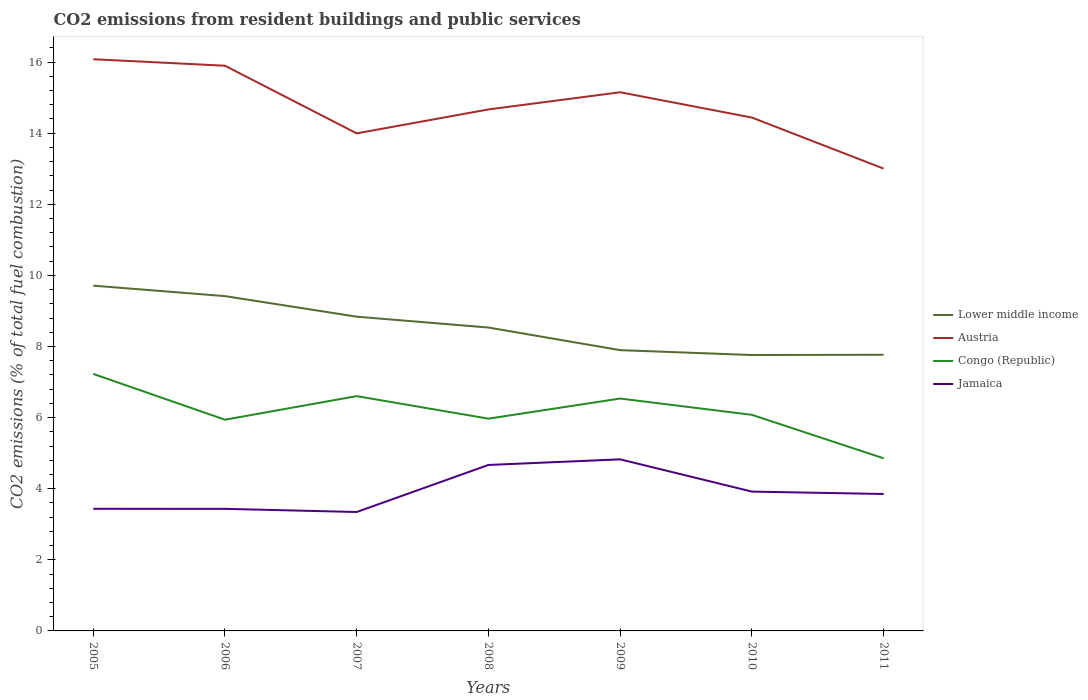How many different coloured lines are there?
Offer a very short reply. 4. Is the number of lines equal to the number of legend labels?
Give a very brief answer. Yes. Across all years, what is the maximum total CO2 emitted in Congo (Republic)?
Make the answer very short. 4.85. In which year was the total CO2 emitted in Lower middle income maximum?
Your answer should be compact. 2010. What is the total total CO2 emitted in Lower middle income in the graph?
Keep it short and to the point. 0.31. What is the difference between the highest and the second highest total CO2 emitted in Austria?
Make the answer very short. 3.08. What is the difference between the highest and the lowest total CO2 emitted in Lower middle income?
Offer a very short reply. 3. Is the total CO2 emitted in Lower middle income strictly greater than the total CO2 emitted in Jamaica over the years?
Make the answer very short. No. How many lines are there?
Your answer should be compact. 4. How many years are there in the graph?
Provide a succinct answer. 7. What is the difference between two consecutive major ticks on the Y-axis?
Your answer should be compact. 2. Where does the legend appear in the graph?
Your answer should be compact. Center right. How many legend labels are there?
Your answer should be very brief. 4. What is the title of the graph?
Provide a succinct answer. CO2 emissions from resident buildings and public services. Does "Spain" appear as one of the legend labels in the graph?
Offer a very short reply. No. What is the label or title of the X-axis?
Ensure brevity in your answer.  Years. What is the label or title of the Y-axis?
Provide a succinct answer. CO2 emissions (% of total fuel combustion). What is the CO2 emissions (% of total fuel combustion) in Lower middle income in 2005?
Make the answer very short. 9.71. What is the CO2 emissions (% of total fuel combustion) in Austria in 2005?
Give a very brief answer. 16.08. What is the CO2 emissions (% of total fuel combustion) in Congo (Republic) in 2005?
Provide a succinct answer. 7.23. What is the CO2 emissions (% of total fuel combustion) of Jamaica in 2005?
Provide a succinct answer. 3.43. What is the CO2 emissions (% of total fuel combustion) of Lower middle income in 2006?
Offer a terse response. 9.42. What is the CO2 emissions (% of total fuel combustion) in Austria in 2006?
Ensure brevity in your answer.  15.9. What is the CO2 emissions (% of total fuel combustion) in Congo (Republic) in 2006?
Give a very brief answer. 5.94. What is the CO2 emissions (% of total fuel combustion) in Jamaica in 2006?
Ensure brevity in your answer.  3.43. What is the CO2 emissions (% of total fuel combustion) in Lower middle income in 2007?
Offer a very short reply. 8.84. What is the CO2 emissions (% of total fuel combustion) of Austria in 2007?
Ensure brevity in your answer.  13.99. What is the CO2 emissions (% of total fuel combustion) of Congo (Republic) in 2007?
Offer a terse response. 6.6. What is the CO2 emissions (% of total fuel combustion) in Jamaica in 2007?
Make the answer very short. 3.34. What is the CO2 emissions (% of total fuel combustion) in Lower middle income in 2008?
Your answer should be compact. 8.53. What is the CO2 emissions (% of total fuel combustion) in Austria in 2008?
Your answer should be compact. 14.67. What is the CO2 emissions (% of total fuel combustion) in Congo (Republic) in 2008?
Your response must be concise. 5.97. What is the CO2 emissions (% of total fuel combustion) of Jamaica in 2008?
Your response must be concise. 4.67. What is the CO2 emissions (% of total fuel combustion) in Lower middle income in 2009?
Give a very brief answer. 7.9. What is the CO2 emissions (% of total fuel combustion) in Austria in 2009?
Offer a terse response. 15.15. What is the CO2 emissions (% of total fuel combustion) in Congo (Republic) in 2009?
Your answer should be very brief. 6.54. What is the CO2 emissions (% of total fuel combustion) of Jamaica in 2009?
Make the answer very short. 4.83. What is the CO2 emissions (% of total fuel combustion) in Lower middle income in 2010?
Your response must be concise. 7.76. What is the CO2 emissions (% of total fuel combustion) of Austria in 2010?
Your answer should be very brief. 14.44. What is the CO2 emissions (% of total fuel combustion) in Congo (Republic) in 2010?
Provide a succinct answer. 6.08. What is the CO2 emissions (% of total fuel combustion) in Jamaica in 2010?
Give a very brief answer. 3.92. What is the CO2 emissions (% of total fuel combustion) in Lower middle income in 2011?
Your answer should be very brief. 7.77. What is the CO2 emissions (% of total fuel combustion) of Austria in 2011?
Provide a succinct answer. 13. What is the CO2 emissions (% of total fuel combustion) in Congo (Republic) in 2011?
Your response must be concise. 4.85. What is the CO2 emissions (% of total fuel combustion) of Jamaica in 2011?
Your answer should be very brief. 3.85. Across all years, what is the maximum CO2 emissions (% of total fuel combustion) of Lower middle income?
Your response must be concise. 9.71. Across all years, what is the maximum CO2 emissions (% of total fuel combustion) of Austria?
Give a very brief answer. 16.08. Across all years, what is the maximum CO2 emissions (% of total fuel combustion) of Congo (Republic)?
Your response must be concise. 7.23. Across all years, what is the maximum CO2 emissions (% of total fuel combustion) of Jamaica?
Keep it short and to the point. 4.83. Across all years, what is the minimum CO2 emissions (% of total fuel combustion) of Lower middle income?
Offer a terse response. 7.76. Across all years, what is the minimum CO2 emissions (% of total fuel combustion) of Austria?
Offer a very short reply. 13. Across all years, what is the minimum CO2 emissions (% of total fuel combustion) in Congo (Republic)?
Offer a very short reply. 4.85. Across all years, what is the minimum CO2 emissions (% of total fuel combustion) in Jamaica?
Offer a terse response. 3.34. What is the total CO2 emissions (% of total fuel combustion) in Lower middle income in the graph?
Keep it short and to the point. 59.92. What is the total CO2 emissions (% of total fuel combustion) in Austria in the graph?
Ensure brevity in your answer.  103.23. What is the total CO2 emissions (% of total fuel combustion) of Congo (Republic) in the graph?
Keep it short and to the point. 43.21. What is the total CO2 emissions (% of total fuel combustion) in Jamaica in the graph?
Your response must be concise. 27.48. What is the difference between the CO2 emissions (% of total fuel combustion) of Lower middle income in 2005 and that in 2006?
Make the answer very short. 0.29. What is the difference between the CO2 emissions (% of total fuel combustion) in Austria in 2005 and that in 2006?
Provide a succinct answer. 0.18. What is the difference between the CO2 emissions (% of total fuel combustion) of Congo (Republic) in 2005 and that in 2006?
Ensure brevity in your answer.  1.29. What is the difference between the CO2 emissions (% of total fuel combustion) of Jamaica in 2005 and that in 2006?
Your answer should be compact. 0. What is the difference between the CO2 emissions (% of total fuel combustion) in Lower middle income in 2005 and that in 2007?
Offer a terse response. 0.87. What is the difference between the CO2 emissions (% of total fuel combustion) of Austria in 2005 and that in 2007?
Ensure brevity in your answer.  2.09. What is the difference between the CO2 emissions (% of total fuel combustion) in Congo (Republic) in 2005 and that in 2007?
Give a very brief answer. 0.63. What is the difference between the CO2 emissions (% of total fuel combustion) in Jamaica in 2005 and that in 2007?
Provide a succinct answer. 0.09. What is the difference between the CO2 emissions (% of total fuel combustion) of Lower middle income in 2005 and that in 2008?
Ensure brevity in your answer.  1.18. What is the difference between the CO2 emissions (% of total fuel combustion) in Austria in 2005 and that in 2008?
Your answer should be compact. 1.41. What is the difference between the CO2 emissions (% of total fuel combustion) of Congo (Republic) in 2005 and that in 2008?
Your answer should be compact. 1.26. What is the difference between the CO2 emissions (% of total fuel combustion) of Jamaica in 2005 and that in 2008?
Ensure brevity in your answer.  -1.23. What is the difference between the CO2 emissions (% of total fuel combustion) of Lower middle income in 2005 and that in 2009?
Give a very brief answer. 1.81. What is the difference between the CO2 emissions (% of total fuel combustion) of Austria in 2005 and that in 2009?
Offer a very short reply. 0.93. What is the difference between the CO2 emissions (% of total fuel combustion) in Congo (Republic) in 2005 and that in 2009?
Ensure brevity in your answer.  0.69. What is the difference between the CO2 emissions (% of total fuel combustion) in Jamaica in 2005 and that in 2009?
Give a very brief answer. -1.39. What is the difference between the CO2 emissions (% of total fuel combustion) of Lower middle income in 2005 and that in 2010?
Ensure brevity in your answer.  1.95. What is the difference between the CO2 emissions (% of total fuel combustion) of Austria in 2005 and that in 2010?
Your response must be concise. 1.64. What is the difference between the CO2 emissions (% of total fuel combustion) of Congo (Republic) in 2005 and that in 2010?
Provide a succinct answer. 1.15. What is the difference between the CO2 emissions (% of total fuel combustion) in Jamaica in 2005 and that in 2010?
Offer a very short reply. -0.48. What is the difference between the CO2 emissions (% of total fuel combustion) of Lower middle income in 2005 and that in 2011?
Your answer should be compact. 1.94. What is the difference between the CO2 emissions (% of total fuel combustion) in Austria in 2005 and that in 2011?
Ensure brevity in your answer.  3.08. What is the difference between the CO2 emissions (% of total fuel combustion) in Congo (Republic) in 2005 and that in 2011?
Keep it short and to the point. 2.37. What is the difference between the CO2 emissions (% of total fuel combustion) of Jamaica in 2005 and that in 2011?
Your answer should be compact. -0.42. What is the difference between the CO2 emissions (% of total fuel combustion) of Lower middle income in 2006 and that in 2007?
Keep it short and to the point. 0.58. What is the difference between the CO2 emissions (% of total fuel combustion) in Austria in 2006 and that in 2007?
Provide a succinct answer. 1.9. What is the difference between the CO2 emissions (% of total fuel combustion) in Congo (Republic) in 2006 and that in 2007?
Provide a succinct answer. -0.66. What is the difference between the CO2 emissions (% of total fuel combustion) in Jamaica in 2006 and that in 2007?
Provide a succinct answer. 0.09. What is the difference between the CO2 emissions (% of total fuel combustion) in Lower middle income in 2006 and that in 2008?
Ensure brevity in your answer.  0.88. What is the difference between the CO2 emissions (% of total fuel combustion) in Austria in 2006 and that in 2008?
Make the answer very short. 1.23. What is the difference between the CO2 emissions (% of total fuel combustion) of Congo (Republic) in 2006 and that in 2008?
Your answer should be compact. -0.03. What is the difference between the CO2 emissions (% of total fuel combustion) in Jamaica in 2006 and that in 2008?
Provide a short and direct response. -1.23. What is the difference between the CO2 emissions (% of total fuel combustion) in Lower middle income in 2006 and that in 2009?
Your answer should be compact. 1.52. What is the difference between the CO2 emissions (% of total fuel combustion) in Austria in 2006 and that in 2009?
Provide a succinct answer. 0.75. What is the difference between the CO2 emissions (% of total fuel combustion) of Congo (Republic) in 2006 and that in 2009?
Offer a terse response. -0.6. What is the difference between the CO2 emissions (% of total fuel combustion) in Jamaica in 2006 and that in 2009?
Offer a very short reply. -1.39. What is the difference between the CO2 emissions (% of total fuel combustion) in Lower middle income in 2006 and that in 2010?
Provide a short and direct response. 1.66. What is the difference between the CO2 emissions (% of total fuel combustion) in Austria in 2006 and that in 2010?
Your answer should be very brief. 1.46. What is the difference between the CO2 emissions (% of total fuel combustion) in Congo (Republic) in 2006 and that in 2010?
Ensure brevity in your answer.  -0.14. What is the difference between the CO2 emissions (% of total fuel combustion) of Jamaica in 2006 and that in 2010?
Your answer should be compact. -0.49. What is the difference between the CO2 emissions (% of total fuel combustion) of Lower middle income in 2006 and that in 2011?
Offer a very short reply. 1.65. What is the difference between the CO2 emissions (% of total fuel combustion) in Austria in 2006 and that in 2011?
Offer a terse response. 2.89. What is the difference between the CO2 emissions (% of total fuel combustion) in Congo (Republic) in 2006 and that in 2011?
Provide a succinct answer. 1.09. What is the difference between the CO2 emissions (% of total fuel combustion) in Jamaica in 2006 and that in 2011?
Offer a terse response. -0.42. What is the difference between the CO2 emissions (% of total fuel combustion) in Lower middle income in 2007 and that in 2008?
Offer a very short reply. 0.31. What is the difference between the CO2 emissions (% of total fuel combustion) of Austria in 2007 and that in 2008?
Offer a very short reply. -0.67. What is the difference between the CO2 emissions (% of total fuel combustion) in Congo (Republic) in 2007 and that in 2008?
Provide a succinct answer. 0.63. What is the difference between the CO2 emissions (% of total fuel combustion) of Jamaica in 2007 and that in 2008?
Your answer should be very brief. -1.32. What is the difference between the CO2 emissions (% of total fuel combustion) of Lower middle income in 2007 and that in 2009?
Give a very brief answer. 0.94. What is the difference between the CO2 emissions (% of total fuel combustion) in Austria in 2007 and that in 2009?
Ensure brevity in your answer.  -1.16. What is the difference between the CO2 emissions (% of total fuel combustion) of Congo (Republic) in 2007 and that in 2009?
Your response must be concise. 0.07. What is the difference between the CO2 emissions (% of total fuel combustion) of Jamaica in 2007 and that in 2009?
Make the answer very short. -1.48. What is the difference between the CO2 emissions (% of total fuel combustion) in Lower middle income in 2007 and that in 2010?
Offer a terse response. 1.08. What is the difference between the CO2 emissions (% of total fuel combustion) of Austria in 2007 and that in 2010?
Make the answer very short. -0.44. What is the difference between the CO2 emissions (% of total fuel combustion) of Congo (Republic) in 2007 and that in 2010?
Give a very brief answer. 0.53. What is the difference between the CO2 emissions (% of total fuel combustion) in Jamaica in 2007 and that in 2010?
Provide a succinct answer. -0.57. What is the difference between the CO2 emissions (% of total fuel combustion) in Lower middle income in 2007 and that in 2011?
Ensure brevity in your answer.  1.07. What is the difference between the CO2 emissions (% of total fuel combustion) of Congo (Republic) in 2007 and that in 2011?
Your response must be concise. 1.75. What is the difference between the CO2 emissions (% of total fuel combustion) of Jamaica in 2007 and that in 2011?
Your response must be concise. -0.51. What is the difference between the CO2 emissions (% of total fuel combustion) of Lower middle income in 2008 and that in 2009?
Your answer should be very brief. 0.64. What is the difference between the CO2 emissions (% of total fuel combustion) in Austria in 2008 and that in 2009?
Ensure brevity in your answer.  -0.48. What is the difference between the CO2 emissions (% of total fuel combustion) of Congo (Republic) in 2008 and that in 2009?
Provide a succinct answer. -0.57. What is the difference between the CO2 emissions (% of total fuel combustion) in Jamaica in 2008 and that in 2009?
Ensure brevity in your answer.  -0.16. What is the difference between the CO2 emissions (% of total fuel combustion) of Lower middle income in 2008 and that in 2010?
Offer a terse response. 0.77. What is the difference between the CO2 emissions (% of total fuel combustion) in Austria in 2008 and that in 2010?
Keep it short and to the point. 0.23. What is the difference between the CO2 emissions (% of total fuel combustion) of Congo (Republic) in 2008 and that in 2010?
Give a very brief answer. -0.11. What is the difference between the CO2 emissions (% of total fuel combustion) in Jamaica in 2008 and that in 2010?
Your response must be concise. 0.75. What is the difference between the CO2 emissions (% of total fuel combustion) in Lower middle income in 2008 and that in 2011?
Provide a succinct answer. 0.77. What is the difference between the CO2 emissions (% of total fuel combustion) of Austria in 2008 and that in 2011?
Offer a very short reply. 1.66. What is the difference between the CO2 emissions (% of total fuel combustion) in Congo (Republic) in 2008 and that in 2011?
Keep it short and to the point. 1.12. What is the difference between the CO2 emissions (% of total fuel combustion) in Jamaica in 2008 and that in 2011?
Keep it short and to the point. 0.82. What is the difference between the CO2 emissions (% of total fuel combustion) in Lower middle income in 2009 and that in 2010?
Provide a succinct answer. 0.14. What is the difference between the CO2 emissions (% of total fuel combustion) in Austria in 2009 and that in 2010?
Your answer should be very brief. 0.71. What is the difference between the CO2 emissions (% of total fuel combustion) of Congo (Republic) in 2009 and that in 2010?
Provide a short and direct response. 0.46. What is the difference between the CO2 emissions (% of total fuel combustion) of Jamaica in 2009 and that in 2010?
Offer a very short reply. 0.91. What is the difference between the CO2 emissions (% of total fuel combustion) of Lower middle income in 2009 and that in 2011?
Your response must be concise. 0.13. What is the difference between the CO2 emissions (% of total fuel combustion) in Austria in 2009 and that in 2011?
Give a very brief answer. 2.15. What is the difference between the CO2 emissions (% of total fuel combustion) in Congo (Republic) in 2009 and that in 2011?
Your response must be concise. 1.68. What is the difference between the CO2 emissions (% of total fuel combustion) in Jamaica in 2009 and that in 2011?
Provide a succinct answer. 0.97. What is the difference between the CO2 emissions (% of total fuel combustion) in Lower middle income in 2010 and that in 2011?
Offer a very short reply. -0.01. What is the difference between the CO2 emissions (% of total fuel combustion) of Austria in 2010 and that in 2011?
Your answer should be very brief. 1.44. What is the difference between the CO2 emissions (% of total fuel combustion) in Congo (Republic) in 2010 and that in 2011?
Give a very brief answer. 1.22. What is the difference between the CO2 emissions (% of total fuel combustion) in Jamaica in 2010 and that in 2011?
Offer a terse response. 0.07. What is the difference between the CO2 emissions (% of total fuel combustion) of Lower middle income in 2005 and the CO2 emissions (% of total fuel combustion) of Austria in 2006?
Your response must be concise. -6.19. What is the difference between the CO2 emissions (% of total fuel combustion) of Lower middle income in 2005 and the CO2 emissions (% of total fuel combustion) of Congo (Republic) in 2006?
Your answer should be very brief. 3.77. What is the difference between the CO2 emissions (% of total fuel combustion) of Lower middle income in 2005 and the CO2 emissions (% of total fuel combustion) of Jamaica in 2006?
Your answer should be very brief. 6.28. What is the difference between the CO2 emissions (% of total fuel combustion) of Austria in 2005 and the CO2 emissions (% of total fuel combustion) of Congo (Republic) in 2006?
Your answer should be very brief. 10.14. What is the difference between the CO2 emissions (% of total fuel combustion) in Austria in 2005 and the CO2 emissions (% of total fuel combustion) in Jamaica in 2006?
Your response must be concise. 12.65. What is the difference between the CO2 emissions (% of total fuel combustion) of Congo (Republic) in 2005 and the CO2 emissions (% of total fuel combustion) of Jamaica in 2006?
Your response must be concise. 3.8. What is the difference between the CO2 emissions (% of total fuel combustion) of Lower middle income in 2005 and the CO2 emissions (% of total fuel combustion) of Austria in 2007?
Give a very brief answer. -4.28. What is the difference between the CO2 emissions (% of total fuel combustion) in Lower middle income in 2005 and the CO2 emissions (% of total fuel combustion) in Congo (Republic) in 2007?
Keep it short and to the point. 3.11. What is the difference between the CO2 emissions (% of total fuel combustion) of Lower middle income in 2005 and the CO2 emissions (% of total fuel combustion) of Jamaica in 2007?
Your answer should be compact. 6.37. What is the difference between the CO2 emissions (% of total fuel combustion) of Austria in 2005 and the CO2 emissions (% of total fuel combustion) of Congo (Republic) in 2007?
Offer a very short reply. 9.48. What is the difference between the CO2 emissions (% of total fuel combustion) of Austria in 2005 and the CO2 emissions (% of total fuel combustion) of Jamaica in 2007?
Keep it short and to the point. 12.73. What is the difference between the CO2 emissions (% of total fuel combustion) of Congo (Republic) in 2005 and the CO2 emissions (% of total fuel combustion) of Jamaica in 2007?
Your response must be concise. 3.88. What is the difference between the CO2 emissions (% of total fuel combustion) of Lower middle income in 2005 and the CO2 emissions (% of total fuel combustion) of Austria in 2008?
Keep it short and to the point. -4.96. What is the difference between the CO2 emissions (% of total fuel combustion) of Lower middle income in 2005 and the CO2 emissions (% of total fuel combustion) of Congo (Republic) in 2008?
Give a very brief answer. 3.74. What is the difference between the CO2 emissions (% of total fuel combustion) in Lower middle income in 2005 and the CO2 emissions (% of total fuel combustion) in Jamaica in 2008?
Your answer should be very brief. 5.04. What is the difference between the CO2 emissions (% of total fuel combustion) in Austria in 2005 and the CO2 emissions (% of total fuel combustion) in Congo (Republic) in 2008?
Provide a succinct answer. 10.11. What is the difference between the CO2 emissions (% of total fuel combustion) of Austria in 2005 and the CO2 emissions (% of total fuel combustion) of Jamaica in 2008?
Your response must be concise. 11.41. What is the difference between the CO2 emissions (% of total fuel combustion) of Congo (Republic) in 2005 and the CO2 emissions (% of total fuel combustion) of Jamaica in 2008?
Your response must be concise. 2.56. What is the difference between the CO2 emissions (% of total fuel combustion) of Lower middle income in 2005 and the CO2 emissions (% of total fuel combustion) of Austria in 2009?
Give a very brief answer. -5.44. What is the difference between the CO2 emissions (% of total fuel combustion) of Lower middle income in 2005 and the CO2 emissions (% of total fuel combustion) of Congo (Republic) in 2009?
Provide a short and direct response. 3.17. What is the difference between the CO2 emissions (% of total fuel combustion) of Lower middle income in 2005 and the CO2 emissions (% of total fuel combustion) of Jamaica in 2009?
Give a very brief answer. 4.88. What is the difference between the CO2 emissions (% of total fuel combustion) of Austria in 2005 and the CO2 emissions (% of total fuel combustion) of Congo (Republic) in 2009?
Give a very brief answer. 9.54. What is the difference between the CO2 emissions (% of total fuel combustion) in Austria in 2005 and the CO2 emissions (% of total fuel combustion) in Jamaica in 2009?
Make the answer very short. 11.25. What is the difference between the CO2 emissions (% of total fuel combustion) in Congo (Republic) in 2005 and the CO2 emissions (% of total fuel combustion) in Jamaica in 2009?
Your answer should be very brief. 2.4. What is the difference between the CO2 emissions (% of total fuel combustion) in Lower middle income in 2005 and the CO2 emissions (% of total fuel combustion) in Austria in 2010?
Provide a succinct answer. -4.73. What is the difference between the CO2 emissions (% of total fuel combustion) of Lower middle income in 2005 and the CO2 emissions (% of total fuel combustion) of Congo (Republic) in 2010?
Make the answer very short. 3.63. What is the difference between the CO2 emissions (% of total fuel combustion) in Lower middle income in 2005 and the CO2 emissions (% of total fuel combustion) in Jamaica in 2010?
Provide a succinct answer. 5.79. What is the difference between the CO2 emissions (% of total fuel combustion) in Austria in 2005 and the CO2 emissions (% of total fuel combustion) in Congo (Republic) in 2010?
Give a very brief answer. 10. What is the difference between the CO2 emissions (% of total fuel combustion) of Austria in 2005 and the CO2 emissions (% of total fuel combustion) of Jamaica in 2010?
Your answer should be compact. 12.16. What is the difference between the CO2 emissions (% of total fuel combustion) of Congo (Republic) in 2005 and the CO2 emissions (% of total fuel combustion) of Jamaica in 2010?
Keep it short and to the point. 3.31. What is the difference between the CO2 emissions (% of total fuel combustion) in Lower middle income in 2005 and the CO2 emissions (% of total fuel combustion) in Austria in 2011?
Keep it short and to the point. -3.29. What is the difference between the CO2 emissions (% of total fuel combustion) of Lower middle income in 2005 and the CO2 emissions (% of total fuel combustion) of Congo (Republic) in 2011?
Provide a succinct answer. 4.86. What is the difference between the CO2 emissions (% of total fuel combustion) of Lower middle income in 2005 and the CO2 emissions (% of total fuel combustion) of Jamaica in 2011?
Your answer should be compact. 5.86. What is the difference between the CO2 emissions (% of total fuel combustion) of Austria in 2005 and the CO2 emissions (% of total fuel combustion) of Congo (Republic) in 2011?
Ensure brevity in your answer.  11.22. What is the difference between the CO2 emissions (% of total fuel combustion) in Austria in 2005 and the CO2 emissions (% of total fuel combustion) in Jamaica in 2011?
Make the answer very short. 12.23. What is the difference between the CO2 emissions (% of total fuel combustion) of Congo (Republic) in 2005 and the CO2 emissions (% of total fuel combustion) of Jamaica in 2011?
Your response must be concise. 3.38. What is the difference between the CO2 emissions (% of total fuel combustion) of Lower middle income in 2006 and the CO2 emissions (% of total fuel combustion) of Austria in 2007?
Keep it short and to the point. -4.58. What is the difference between the CO2 emissions (% of total fuel combustion) of Lower middle income in 2006 and the CO2 emissions (% of total fuel combustion) of Congo (Republic) in 2007?
Your answer should be very brief. 2.81. What is the difference between the CO2 emissions (% of total fuel combustion) of Lower middle income in 2006 and the CO2 emissions (% of total fuel combustion) of Jamaica in 2007?
Make the answer very short. 6.07. What is the difference between the CO2 emissions (% of total fuel combustion) of Austria in 2006 and the CO2 emissions (% of total fuel combustion) of Congo (Republic) in 2007?
Offer a very short reply. 9.29. What is the difference between the CO2 emissions (% of total fuel combustion) in Austria in 2006 and the CO2 emissions (% of total fuel combustion) in Jamaica in 2007?
Offer a very short reply. 12.55. What is the difference between the CO2 emissions (% of total fuel combustion) in Congo (Republic) in 2006 and the CO2 emissions (% of total fuel combustion) in Jamaica in 2007?
Make the answer very short. 2.6. What is the difference between the CO2 emissions (% of total fuel combustion) of Lower middle income in 2006 and the CO2 emissions (% of total fuel combustion) of Austria in 2008?
Your answer should be compact. -5.25. What is the difference between the CO2 emissions (% of total fuel combustion) of Lower middle income in 2006 and the CO2 emissions (% of total fuel combustion) of Congo (Republic) in 2008?
Offer a very short reply. 3.45. What is the difference between the CO2 emissions (% of total fuel combustion) in Lower middle income in 2006 and the CO2 emissions (% of total fuel combustion) in Jamaica in 2008?
Ensure brevity in your answer.  4.75. What is the difference between the CO2 emissions (% of total fuel combustion) of Austria in 2006 and the CO2 emissions (% of total fuel combustion) of Congo (Republic) in 2008?
Provide a short and direct response. 9.93. What is the difference between the CO2 emissions (% of total fuel combustion) in Austria in 2006 and the CO2 emissions (% of total fuel combustion) in Jamaica in 2008?
Your answer should be very brief. 11.23. What is the difference between the CO2 emissions (% of total fuel combustion) in Congo (Republic) in 2006 and the CO2 emissions (% of total fuel combustion) in Jamaica in 2008?
Provide a short and direct response. 1.27. What is the difference between the CO2 emissions (% of total fuel combustion) in Lower middle income in 2006 and the CO2 emissions (% of total fuel combustion) in Austria in 2009?
Give a very brief answer. -5.73. What is the difference between the CO2 emissions (% of total fuel combustion) in Lower middle income in 2006 and the CO2 emissions (% of total fuel combustion) in Congo (Republic) in 2009?
Offer a very short reply. 2.88. What is the difference between the CO2 emissions (% of total fuel combustion) of Lower middle income in 2006 and the CO2 emissions (% of total fuel combustion) of Jamaica in 2009?
Offer a very short reply. 4.59. What is the difference between the CO2 emissions (% of total fuel combustion) of Austria in 2006 and the CO2 emissions (% of total fuel combustion) of Congo (Republic) in 2009?
Make the answer very short. 9.36. What is the difference between the CO2 emissions (% of total fuel combustion) of Austria in 2006 and the CO2 emissions (% of total fuel combustion) of Jamaica in 2009?
Give a very brief answer. 11.07. What is the difference between the CO2 emissions (% of total fuel combustion) of Congo (Republic) in 2006 and the CO2 emissions (% of total fuel combustion) of Jamaica in 2009?
Your answer should be compact. 1.11. What is the difference between the CO2 emissions (% of total fuel combustion) in Lower middle income in 2006 and the CO2 emissions (% of total fuel combustion) in Austria in 2010?
Give a very brief answer. -5.02. What is the difference between the CO2 emissions (% of total fuel combustion) of Lower middle income in 2006 and the CO2 emissions (% of total fuel combustion) of Congo (Republic) in 2010?
Ensure brevity in your answer.  3.34. What is the difference between the CO2 emissions (% of total fuel combustion) in Lower middle income in 2006 and the CO2 emissions (% of total fuel combustion) in Jamaica in 2010?
Provide a short and direct response. 5.5. What is the difference between the CO2 emissions (% of total fuel combustion) in Austria in 2006 and the CO2 emissions (% of total fuel combustion) in Congo (Republic) in 2010?
Offer a very short reply. 9.82. What is the difference between the CO2 emissions (% of total fuel combustion) in Austria in 2006 and the CO2 emissions (% of total fuel combustion) in Jamaica in 2010?
Make the answer very short. 11.98. What is the difference between the CO2 emissions (% of total fuel combustion) of Congo (Republic) in 2006 and the CO2 emissions (% of total fuel combustion) of Jamaica in 2010?
Offer a very short reply. 2.02. What is the difference between the CO2 emissions (% of total fuel combustion) of Lower middle income in 2006 and the CO2 emissions (% of total fuel combustion) of Austria in 2011?
Keep it short and to the point. -3.59. What is the difference between the CO2 emissions (% of total fuel combustion) of Lower middle income in 2006 and the CO2 emissions (% of total fuel combustion) of Congo (Republic) in 2011?
Give a very brief answer. 4.56. What is the difference between the CO2 emissions (% of total fuel combustion) in Lower middle income in 2006 and the CO2 emissions (% of total fuel combustion) in Jamaica in 2011?
Give a very brief answer. 5.57. What is the difference between the CO2 emissions (% of total fuel combustion) of Austria in 2006 and the CO2 emissions (% of total fuel combustion) of Congo (Republic) in 2011?
Your answer should be compact. 11.04. What is the difference between the CO2 emissions (% of total fuel combustion) in Austria in 2006 and the CO2 emissions (% of total fuel combustion) in Jamaica in 2011?
Provide a succinct answer. 12.04. What is the difference between the CO2 emissions (% of total fuel combustion) of Congo (Republic) in 2006 and the CO2 emissions (% of total fuel combustion) of Jamaica in 2011?
Your answer should be compact. 2.09. What is the difference between the CO2 emissions (% of total fuel combustion) in Lower middle income in 2007 and the CO2 emissions (% of total fuel combustion) in Austria in 2008?
Your answer should be very brief. -5.83. What is the difference between the CO2 emissions (% of total fuel combustion) of Lower middle income in 2007 and the CO2 emissions (% of total fuel combustion) of Congo (Republic) in 2008?
Offer a terse response. 2.87. What is the difference between the CO2 emissions (% of total fuel combustion) in Lower middle income in 2007 and the CO2 emissions (% of total fuel combustion) in Jamaica in 2008?
Ensure brevity in your answer.  4.17. What is the difference between the CO2 emissions (% of total fuel combustion) in Austria in 2007 and the CO2 emissions (% of total fuel combustion) in Congo (Republic) in 2008?
Make the answer very short. 8.02. What is the difference between the CO2 emissions (% of total fuel combustion) of Austria in 2007 and the CO2 emissions (% of total fuel combustion) of Jamaica in 2008?
Your answer should be compact. 9.33. What is the difference between the CO2 emissions (% of total fuel combustion) in Congo (Republic) in 2007 and the CO2 emissions (% of total fuel combustion) in Jamaica in 2008?
Provide a short and direct response. 1.94. What is the difference between the CO2 emissions (% of total fuel combustion) of Lower middle income in 2007 and the CO2 emissions (% of total fuel combustion) of Austria in 2009?
Offer a terse response. -6.31. What is the difference between the CO2 emissions (% of total fuel combustion) in Lower middle income in 2007 and the CO2 emissions (% of total fuel combustion) in Congo (Republic) in 2009?
Provide a succinct answer. 2.3. What is the difference between the CO2 emissions (% of total fuel combustion) in Lower middle income in 2007 and the CO2 emissions (% of total fuel combustion) in Jamaica in 2009?
Ensure brevity in your answer.  4.01. What is the difference between the CO2 emissions (% of total fuel combustion) in Austria in 2007 and the CO2 emissions (% of total fuel combustion) in Congo (Republic) in 2009?
Provide a succinct answer. 7.46. What is the difference between the CO2 emissions (% of total fuel combustion) of Austria in 2007 and the CO2 emissions (% of total fuel combustion) of Jamaica in 2009?
Keep it short and to the point. 9.17. What is the difference between the CO2 emissions (% of total fuel combustion) in Congo (Republic) in 2007 and the CO2 emissions (% of total fuel combustion) in Jamaica in 2009?
Your answer should be very brief. 1.78. What is the difference between the CO2 emissions (% of total fuel combustion) of Lower middle income in 2007 and the CO2 emissions (% of total fuel combustion) of Congo (Republic) in 2010?
Provide a short and direct response. 2.76. What is the difference between the CO2 emissions (% of total fuel combustion) in Lower middle income in 2007 and the CO2 emissions (% of total fuel combustion) in Jamaica in 2010?
Keep it short and to the point. 4.92. What is the difference between the CO2 emissions (% of total fuel combustion) of Austria in 2007 and the CO2 emissions (% of total fuel combustion) of Congo (Republic) in 2010?
Offer a terse response. 7.92. What is the difference between the CO2 emissions (% of total fuel combustion) of Austria in 2007 and the CO2 emissions (% of total fuel combustion) of Jamaica in 2010?
Your answer should be compact. 10.08. What is the difference between the CO2 emissions (% of total fuel combustion) in Congo (Republic) in 2007 and the CO2 emissions (% of total fuel combustion) in Jamaica in 2010?
Ensure brevity in your answer.  2.69. What is the difference between the CO2 emissions (% of total fuel combustion) of Lower middle income in 2007 and the CO2 emissions (% of total fuel combustion) of Austria in 2011?
Your answer should be compact. -4.16. What is the difference between the CO2 emissions (% of total fuel combustion) of Lower middle income in 2007 and the CO2 emissions (% of total fuel combustion) of Congo (Republic) in 2011?
Make the answer very short. 3.98. What is the difference between the CO2 emissions (% of total fuel combustion) in Lower middle income in 2007 and the CO2 emissions (% of total fuel combustion) in Jamaica in 2011?
Offer a very short reply. 4.99. What is the difference between the CO2 emissions (% of total fuel combustion) in Austria in 2007 and the CO2 emissions (% of total fuel combustion) in Congo (Republic) in 2011?
Provide a succinct answer. 9.14. What is the difference between the CO2 emissions (% of total fuel combustion) of Austria in 2007 and the CO2 emissions (% of total fuel combustion) of Jamaica in 2011?
Your answer should be very brief. 10.14. What is the difference between the CO2 emissions (% of total fuel combustion) in Congo (Republic) in 2007 and the CO2 emissions (% of total fuel combustion) in Jamaica in 2011?
Provide a short and direct response. 2.75. What is the difference between the CO2 emissions (% of total fuel combustion) in Lower middle income in 2008 and the CO2 emissions (% of total fuel combustion) in Austria in 2009?
Keep it short and to the point. -6.62. What is the difference between the CO2 emissions (% of total fuel combustion) of Lower middle income in 2008 and the CO2 emissions (% of total fuel combustion) of Congo (Republic) in 2009?
Offer a terse response. 2. What is the difference between the CO2 emissions (% of total fuel combustion) in Lower middle income in 2008 and the CO2 emissions (% of total fuel combustion) in Jamaica in 2009?
Your answer should be compact. 3.71. What is the difference between the CO2 emissions (% of total fuel combustion) in Austria in 2008 and the CO2 emissions (% of total fuel combustion) in Congo (Republic) in 2009?
Provide a succinct answer. 8.13. What is the difference between the CO2 emissions (% of total fuel combustion) in Austria in 2008 and the CO2 emissions (% of total fuel combustion) in Jamaica in 2009?
Your response must be concise. 9.84. What is the difference between the CO2 emissions (% of total fuel combustion) in Congo (Republic) in 2008 and the CO2 emissions (% of total fuel combustion) in Jamaica in 2009?
Make the answer very short. 1.14. What is the difference between the CO2 emissions (% of total fuel combustion) of Lower middle income in 2008 and the CO2 emissions (% of total fuel combustion) of Austria in 2010?
Make the answer very short. -5.91. What is the difference between the CO2 emissions (% of total fuel combustion) of Lower middle income in 2008 and the CO2 emissions (% of total fuel combustion) of Congo (Republic) in 2010?
Offer a terse response. 2.46. What is the difference between the CO2 emissions (% of total fuel combustion) in Lower middle income in 2008 and the CO2 emissions (% of total fuel combustion) in Jamaica in 2010?
Keep it short and to the point. 4.61. What is the difference between the CO2 emissions (% of total fuel combustion) in Austria in 2008 and the CO2 emissions (% of total fuel combustion) in Congo (Republic) in 2010?
Provide a short and direct response. 8.59. What is the difference between the CO2 emissions (% of total fuel combustion) of Austria in 2008 and the CO2 emissions (% of total fuel combustion) of Jamaica in 2010?
Your response must be concise. 10.75. What is the difference between the CO2 emissions (% of total fuel combustion) in Congo (Republic) in 2008 and the CO2 emissions (% of total fuel combustion) in Jamaica in 2010?
Give a very brief answer. 2.05. What is the difference between the CO2 emissions (% of total fuel combustion) of Lower middle income in 2008 and the CO2 emissions (% of total fuel combustion) of Austria in 2011?
Provide a short and direct response. -4.47. What is the difference between the CO2 emissions (% of total fuel combustion) of Lower middle income in 2008 and the CO2 emissions (% of total fuel combustion) of Congo (Republic) in 2011?
Offer a terse response. 3.68. What is the difference between the CO2 emissions (% of total fuel combustion) in Lower middle income in 2008 and the CO2 emissions (% of total fuel combustion) in Jamaica in 2011?
Provide a succinct answer. 4.68. What is the difference between the CO2 emissions (% of total fuel combustion) in Austria in 2008 and the CO2 emissions (% of total fuel combustion) in Congo (Republic) in 2011?
Provide a short and direct response. 9.81. What is the difference between the CO2 emissions (% of total fuel combustion) of Austria in 2008 and the CO2 emissions (% of total fuel combustion) of Jamaica in 2011?
Your response must be concise. 10.82. What is the difference between the CO2 emissions (% of total fuel combustion) of Congo (Republic) in 2008 and the CO2 emissions (% of total fuel combustion) of Jamaica in 2011?
Your answer should be compact. 2.12. What is the difference between the CO2 emissions (% of total fuel combustion) of Lower middle income in 2009 and the CO2 emissions (% of total fuel combustion) of Austria in 2010?
Provide a short and direct response. -6.54. What is the difference between the CO2 emissions (% of total fuel combustion) of Lower middle income in 2009 and the CO2 emissions (% of total fuel combustion) of Congo (Republic) in 2010?
Give a very brief answer. 1.82. What is the difference between the CO2 emissions (% of total fuel combustion) of Lower middle income in 2009 and the CO2 emissions (% of total fuel combustion) of Jamaica in 2010?
Offer a terse response. 3.98. What is the difference between the CO2 emissions (% of total fuel combustion) in Austria in 2009 and the CO2 emissions (% of total fuel combustion) in Congo (Republic) in 2010?
Provide a short and direct response. 9.07. What is the difference between the CO2 emissions (% of total fuel combustion) of Austria in 2009 and the CO2 emissions (% of total fuel combustion) of Jamaica in 2010?
Offer a terse response. 11.23. What is the difference between the CO2 emissions (% of total fuel combustion) of Congo (Republic) in 2009 and the CO2 emissions (% of total fuel combustion) of Jamaica in 2010?
Provide a short and direct response. 2.62. What is the difference between the CO2 emissions (% of total fuel combustion) in Lower middle income in 2009 and the CO2 emissions (% of total fuel combustion) in Austria in 2011?
Offer a terse response. -5.11. What is the difference between the CO2 emissions (% of total fuel combustion) of Lower middle income in 2009 and the CO2 emissions (% of total fuel combustion) of Congo (Republic) in 2011?
Offer a very short reply. 3.04. What is the difference between the CO2 emissions (% of total fuel combustion) of Lower middle income in 2009 and the CO2 emissions (% of total fuel combustion) of Jamaica in 2011?
Offer a very short reply. 4.05. What is the difference between the CO2 emissions (% of total fuel combustion) of Austria in 2009 and the CO2 emissions (% of total fuel combustion) of Congo (Republic) in 2011?
Offer a very short reply. 10.3. What is the difference between the CO2 emissions (% of total fuel combustion) of Austria in 2009 and the CO2 emissions (% of total fuel combustion) of Jamaica in 2011?
Your answer should be compact. 11.3. What is the difference between the CO2 emissions (% of total fuel combustion) in Congo (Republic) in 2009 and the CO2 emissions (% of total fuel combustion) in Jamaica in 2011?
Offer a very short reply. 2.68. What is the difference between the CO2 emissions (% of total fuel combustion) in Lower middle income in 2010 and the CO2 emissions (% of total fuel combustion) in Austria in 2011?
Give a very brief answer. -5.24. What is the difference between the CO2 emissions (% of total fuel combustion) of Lower middle income in 2010 and the CO2 emissions (% of total fuel combustion) of Congo (Republic) in 2011?
Your answer should be compact. 2.91. What is the difference between the CO2 emissions (% of total fuel combustion) in Lower middle income in 2010 and the CO2 emissions (% of total fuel combustion) in Jamaica in 2011?
Give a very brief answer. 3.91. What is the difference between the CO2 emissions (% of total fuel combustion) in Austria in 2010 and the CO2 emissions (% of total fuel combustion) in Congo (Republic) in 2011?
Provide a succinct answer. 9.58. What is the difference between the CO2 emissions (% of total fuel combustion) of Austria in 2010 and the CO2 emissions (% of total fuel combustion) of Jamaica in 2011?
Ensure brevity in your answer.  10.59. What is the difference between the CO2 emissions (% of total fuel combustion) in Congo (Republic) in 2010 and the CO2 emissions (% of total fuel combustion) in Jamaica in 2011?
Offer a terse response. 2.23. What is the average CO2 emissions (% of total fuel combustion) in Lower middle income per year?
Ensure brevity in your answer.  8.56. What is the average CO2 emissions (% of total fuel combustion) in Austria per year?
Provide a succinct answer. 14.75. What is the average CO2 emissions (% of total fuel combustion) of Congo (Republic) per year?
Offer a very short reply. 6.17. What is the average CO2 emissions (% of total fuel combustion) in Jamaica per year?
Offer a terse response. 3.93. In the year 2005, what is the difference between the CO2 emissions (% of total fuel combustion) of Lower middle income and CO2 emissions (% of total fuel combustion) of Austria?
Offer a very short reply. -6.37. In the year 2005, what is the difference between the CO2 emissions (% of total fuel combustion) of Lower middle income and CO2 emissions (% of total fuel combustion) of Congo (Republic)?
Offer a very short reply. 2.48. In the year 2005, what is the difference between the CO2 emissions (% of total fuel combustion) of Lower middle income and CO2 emissions (% of total fuel combustion) of Jamaica?
Your answer should be very brief. 6.28. In the year 2005, what is the difference between the CO2 emissions (% of total fuel combustion) of Austria and CO2 emissions (% of total fuel combustion) of Congo (Republic)?
Keep it short and to the point. 8.85. In the year 2005, what is the difference between the CO2 emissions (% of total fuel combustion) of Austria and CO2 emissions (% of total fuel combustion) of Jamaica?
Make the answer very short. 12.64. In the year 2005, what is the difference between the CO2 emissions (% of total fuel combustion) of Congo (Republic) and CO2 emissions (% of total fuel combustion) of Jamaica?
Keep it short and to the point. 3.79. In the year 2006, what is the difference between the CO2 emissions (% of total fuel combustion) of Lower middle income and CO2 emissions (% of total fuel combustion) of Austria?
Keep it short and to the point. -6.48. In the year 2006, what is the difference between the CO2 emissions (% of total fuel combustion) of Lower middle income and CO2 emissions (% of total fuel combustion) of Congo (Republic)?
Offer a very short reply. 3.48. In the year 2006, what is the difference between the CO2 emissions (% of total fuel combustion) in Lower middle income and CO2 emissions (% of total fuel combustion) in Jamaica?
Provide a succinct answer. 5.98. In the year 2006, what is the difference between the CO2 emissions (% of total fuel combustion) of Austria and CO2 emissions (% of total fuel combustion) of Congo (Republic)?
Make the answer very short. 9.96. In the year 2006, what is the difference between the CO2 emissions (% of total fuel combustion) in Austria and CO2 emissions (% of total fuel combustion) in Jamaica?
Provide a succinct answer. 12.46. In the year 2006, what is the difference between the CO2 emissions (% of total fuel combustion) of Congo (Republic) and CO2 emissions (% of total fuel combustion) of Jamaica?
Give a very brief answer. 2.51. In the year 2007, what is the difference between the CO2 emissions (% of total fuel combustion) of Lower middle income and CO2 emissions (% of total fuel combustion) of Austria?
Give a very brief answer. -5.16. In the year 2007, what is the difference between the CO2 emissions (% of total fuel combustion) of Lower middle income and CO2 emissions (% of total fuel combustion) of Congo (Republic)?
Give a very brief answer. 2.23. In the year 2007, what is the difference between the CO2 emissions (% of total fuel combustion) of Lower middle income and CO2 emissions (% of total fuel combustion) of Jamaica?
Keep it short and to the point. 5.49. In the year 2007, what is the difference between the CO2 emissions (% of total fuel combustion) of Austria and CO2 emissions (% of total fuel combustion) of Congo (Republic)?
Offer a terse response. 7.39. In the year 2007, what is the difference between the CO2 emissions (% of total fuel combustion) in Austria and CO2 emissions (% of total fuel combustion) in Jamaica?
Keep it short and to the point. 10.65. In the year 2007, what is the difference between the CO2 emissions (% of total fuel combustion) of Congo (Republic) and CO2 emissions (% of total fuel combustion) of Jamaica?
Keep it short and to the point. 3.26. In the year 2008, what is the difference between the CO2 emissions (% of total fuel combustion) of Lower middle income and CO2 emissions (% of total fuel combustion) of Austria?
Your answer should be compact. -6.13. In the year 2008, what is the difference between the CO2 emissions (% of total fuel combustion) of Lower middle income and CO2 emissions (% of total fuel combustion) of Congo (Republic)?
Your answer should be very brief. 2.56. In the year 2008, what is the difference between the CO2 emissions (% of total fuel combustion) of Lower middle income and CO2 emissions (% of total fuel combustion) of Jamaica?
Offer a terse response. 3.86. In the year 2008, what is the difference between the CO2 emissions (% of total fuel combustion) of Austria and CO2 emissions (% of total fuel combustion) of Congo (Republic)?
Your answer should be compact. 8.7. In the year 2008, what is the difference between the CO2 emissions (% of total fuel combustion) in Austria and CO2 emissions (% of total fuel combustion) in Jamaica?
Give a very brief answer. 10. In the year 2008, what is the difference between the CO2 emissions (% of total fuel combustion) in Congo (Republic) and CO2 emissions (% of total fuel combustion) in Jamaica?
Your answer should be very brief. 1.3. In the year 2009, what is the difference between the CO2 emissions (% of total fuel combustion) in Lower middle income and CO2 emissions (% of total fuel combustion) in Austria?
Your response must be concise. -7.25. In the year 2009, what is the difference between the CO2 emissions (% of total fuel combustion) of Lower middle income and CO2 emissions (% of total fuel combustion) of Congo (Republic)?
Your response must be concise. 1.36. In the year 2009, what is the difference between the CO2 emissions (% of total fuel combustion) in Lower middle income and CO2 emissions (% of total fuel combustion) in Jamaica?
Your answer should be very brief. 3.07. In the year 2009, what is the difference between the CO2 emissions (% of total fuel combustion) of Austria and CO2 emissions (% of total fuel combustion) of Congo (Republic)?
Give a very brief answer. 8.61. In the year 2009, what is the difference between the CO2 emissions (% of total fuel combustion) of Austria and CO2 emissions (% of total fuel combustion) of Jamaica?
Ensure brevity in your answer.  10.32. In the year 2009, what is the difference between the CO2 emissions (% of total fuel combustion) of Congo (Republic) and CO2 emissions (% of total fuel combustion) of Jamaica?
Provide a short and direct response. 1.71. In the year 2010, what is the difference between the CO2 emissions (% of total fuel combustion) of Lower middle income and CO2 emissions (% of total fuel combustion) of Austria?
Keep it short and to the point. -6.68. In the year 2010, what is the difference between the CO2 emissions (% of total fuel combustion) of Lower middle income and CO2 emissions (% of total fuel combustion) of Congo (Republic)?
Offer a very short reply. 1.68. In the year 2010, what is the difference between the CO2 emissions (% of total fuel combustion) in Lower middle income and CO2 emissions (% of total fuel combustion) in Jamaica?
Your response must be concise. 3.84. In the year 2010, what is the difference between the CO2 emissions (% of total fuel combustion) of Austria and CO2 emissions (% of total fuel combustion) of Congo (Republic)?
Make the answer very short. 8.36. In the year 2010, what is the difference between the CO2 emissions (% of total fuel combustion) of Austria and CO2 emissions (% of total fuel combustion) of Jamaica?
Offer a terse response. 10.52. In the year 2010, what is the difference between the CO2 emissions (% of total fuel combustion) in Congo (Republic) and CO2 emissions (% of total fuel combustion) in Jamaica?
Provide a succinct answer. 2.16. In the year 2011, what is the difference between the CO2 emissions (% of total fuel combustion) in Lower middle income and CO2 emissions (% of total fuel combustion) in Austria?
Offer a terse response. -5.24. In the year 2011, what is the difference between the CO2 emissions (% of total fuel combustion) in Lower middle income and CO2 emissions (% of total fuel combustion) in Congo (Republic)?
Ensure brevity in your answer.  2.91. In the year 2011, what is the difference between the CO2 emissions (% of total fuel combustion) in Lower middle income and CO2 emissions (% of total fuel combustion) in Jamaica?
Keep it short and to the point. 3.92. In the year 2011, what is the difference between the CO2 emissions (% of total fuel combustion) of Austria and CO2 emissions (% of total fuel combustion) of Congo (Republic)?
Ensure brevity in your answer.  8.15. In the year 2011, what is the difference between the CO2 emissions (% of total fuel combustion) in Austria and CO2 emissions (% of total fuel combustion) in Jamaica?
Offer a terse response. 9.15. In the year 2011, what is the difference between the CO2 emissions (% of total fuel combustion) of Congo (Republic) and CO2 emissions (% of total fuel combustion) of Jamaica?
Your answer should be compact. 1. What is the ratio of the CO2 emissions (% of total fuel combustion) of Lower middle income in 2005 to that in 2006?
Offer a terse response. 1.03. What is the ratio of the CO2 emissions (% of total fuel combustion) in Austria in 2005 to that in 2006?
Keep it short and to the point. 1.01. What is the ratio of the CO2 emissions (% of total fuel combustion) of Congo (Republic) in 2005 to that in 2006?
Provide a succinct answer. 1.22. What is the ratio of the CO2 emissions (% of total fuel combustion) in Lower middle income in 2005 to that in 2007?
Your response must be concise. 1.1. What is the ratio of the CO2 emissions (% of total fuel combustion) in Austria in 2005 to that in 2007?
Offer a very short reply. 1.15. What is the ratio of the CO2 emissions (% of total fuel combustion) of Congo (Republic) in 2005 to that in 2007?
Your answer should be compact. 1.09. What is the ratio of the CO2 emissions (% of total fuel combustion) of Jamaica in 2005 to that in 2007?
Keep it short and to the point. 1.03. What is the ratio of the CO2 emissions (% of total fuel combustion) in Lower middle income in 2005 to that in 2008?
Provide a succinct answer. 1.14. What is the ratio of the CO2 emissions (% of total fuel combustion) of Austria in 2005 to that in 2008?
Provide a succinct answer. 1.1. What is the ratio of the CO2 emissions (% of total fuel combustion) in Congo (Republic) in 2005 to that in 2008?
Your answer should be compact. 1.21. What is the ratio of the CO2 emissions (% of total fuel combustion) of Jamaica in 2005 to that in 2008?
Provide a short and direct response. 0.74. What is the ratio of the CO2 emissions (% of total fuel combustion) in Lower middle income in 2005 to that in 2009?
Ensure brevity in your answer.  1.23. What is the ratio of the CO2 emissions (% of total fuel combustion) in Austria in 2005 to that in 2009?
Your response must be concise. 1.06. What is the ratio of the CO2 emissions (% of total fuel combustion) of Congo (Republic) in 2005 to that in 2009?
Give a very brief answer. 1.11. What is the ratio of the CO2 emissions (% of total fuel combustion) in Jamaica in 2005 to that in 2009?
Keep it short and to the point. 0.71. What is the ratio of the CO2 emissions (% of total fuel combustion) in Lower middle income in 2005 to that in 2010?
Provide a succinct answer. 1.25. What is the ratio of the CO2 emissions (% of total fuel combustion) in Austria in 2005 to that in 2010?
Offer a terse response. 1.11. What is the ratio of the CO2 emissions (% of total fuel combustion) of Congo (Republic) in 2005 to that in 2010?
Your answer should be very brief. 1.19. What is the ratio of the CO2 emissions (% of total fuel combustion) in Jamaica in 2005 to that in 2010?
Provide a short and direct response. 0.88. What is the ratio of the CO2 emissions (% of total fuel combustion) of Lower middle income in 2005 to that in 2011?
Your answer should be very brief. 1.25. What is the ratio of the CO2 emissions (% of total fuel combustion) in Austria in 2005 to that in 2011?
Your answer should be very brief. 1.24. What is the ratio of the CO2 emissions (% of total fuel combustion) in Congo (Republic) in 2005 to that in 2011?
Ensure brevity in your answer.  1.49. What is the ratio of the CO2 emissions (% of total fuel combustion) of Jamaica in 2005 to that in 2011?
Offer a terse response. 0.89. What is the ratio of the CO2 emissions (% of total fuel combustion) in Lower middle income in 2006 to that in 2007?
Make the answer very short. 1.07. What is the ratio of the CO2 emissions (% of total fuel combustion) in Austria in 2006 to that in 2007?
Offer a very short reply. 1.14. What is the ratio of the CO2 emissions (% of total fuel combustion) of Congo (Republic) in 2006 to that in 2007?
Offer a terse response. 0.9. What is the ratio of the CO2 emissions (% of total fuel combustion) of Jamaica in 2006 to that in 2007?
Keep it short and to the point. 1.03. What is the ratio of the CO2 emissions (% of total fuel combustion) of Lower middle income in 2006 to that in 2008?
Your answer should be very brief. 1.1. What is the ratio of the CO2 emissions (% of total fuel combustion) of Austria in 2006 to that in 2008?
Provide a short and direct response. 1.08. What is the ratio of the CO2 emissions (% of total fuel combustion) in Congo (Republic) in 2006 to that in 2008?
Provide a succinct answer. 0.99. What is the ratio of the CO2 emissions (% of total fuel combustion) of Jamaica in 2006 to that in 2008?
Keep it short and to the point. 0.74. What is the ratio of the CO2 emissions (% of total fuel combustion) of Lower middle income in 2006 to that in 2009?
Offer a very short reply. 1.19. What is the ratio of the CO2 emissions (% of total fuel combustion) of Austria in 2006 to that in 2009?
Ensure brevity in your answer.  1.05. What is the ratio of the CO2 emissions (% of total fuel combustion) in Congo (Republic) in 2006 to that in 2009?
Make the answer very short. 0.91. What is the ratio of the CO2 emissions (% of total fuel combustion) of Jamaica in 2006 to that in 2009?
Your answer should be compact. 0.71. What is the ratio of the CO2 emissions (% of total fuel combustion) in Lower middle income in 2006 to that in 2010?
Provide a succinct answer. 1.21. What is the ratio of the CO2 emissions (% of total fuel combustion) of Austria in 2006 to that in 2010?
Provide a short and direct response. 1.1. What is the ratio of the CO2 emissions (% of total fuel combustion) in Congo (Republic) in 2006 to that in 2010?
Provide a short and direct response. 0.98. What is the ratio of the CO2 emissions (% of total fuel combustion) of Jamaica in 2006 to that in 2010?
Keep it short and to the point. 0.88. What is the ratio of the CO2 emissions (% of total fuel combustion) in Lower middle income in 2006 to that in 2011?
Your response must be concise. 1.21. What is the ratio of the CO2 emissions (% of total fuel combustion) in Austria in 2006 to that in 2011?
Offer a very short reply. 1.22. What is the ratio of the CO2 emissions (% of total fuel combustion) in Congo (Republic) in 2006 to that in 2011?
Your answer should be compact. 1.22. What is the ratio of the CO2 emissions (% of total fuel combustion) in Jamaica in 2006 to that in 2011?
Make the answer very short. 0.89. What is the ratio of the CO2 emissions (% of total fuel combustion) in Lower middle income in 2007 to that in 2008?
Provide a short and direct response. 1.04. What is the ratio of the CO2 emissions (% of total fuel combustion) in Austria in 2007 to that in 2008?
Provide a succinct answer. 0.95. What is the ratio of the CO2 emissions (% of total fuel combustion) in Congo (Republic) in 2007 to that in 2008?
Give a very brief answer. 1.11. What is the ratio of the CO2 emissions (% of total fuel combustion) of Jamaica in 2007 to that in 2008?
Offer a very short reply. 0.72. What is the ratio of the CO2 emissions (% of total fuel combustion) in Lower middle income in 2007 to that in 2009?
Provide a short and direct response. 1.12. What is the ratio of the CO2 emissions (% of total fuel combustion) of Austria in 2007 to that in 2009?
Provide a short and direct response. 0.92. What is the ratio of the CO2 emissions (% of total fuel combustion) in Congo (Republic) in 2007 to that in 2009?
Provide a short and direct response. 1.01. What is the ratio of the CO2 emissions (% of total fuel combustion) in Jamaica in 2007 to that in 2009?
Offer a very short reply. 0.69. What is the ratio of the CO2 emissions (% of total fuel combustion) in Lower middle income in 2007 to that in 2010?
Give a very brief answer. 1.14. What is the ratio of the CO2 emissions (% of total fuel combustion) in Austria in 2007 to that in 2010?
Provide a short and direct response. 0.97. What is the ratio of the CO2 emissions (% of total fuel combustion) in Congo (Republic) in 2007 to that in 2010?
Your answer should be compact. 1.09. What is the ratio of the CO2 emissions (% of total fuel combustion) of Jamaica in 2007 to that in 2010?
Provide a succinct answer. 0.85. What is the ratio of the CO2 emissions (% of total fuel combustion) in Lower middle income in 2007 to that in 2011?
Make the answer very short. 1.14. What is the ratio of the CO2 emissions (% of total fuel combustion) of Austria in 2007 to that in 2011?
Your answer should be very brief. 1.08. What is the ratio of the CO2 emissions (% of total fuel combustion) in Congo (Republic) in 2007 to that in 2011?
Offer a very short reply. 1.36. What is the ratio of the CO2 emissions (% of total fuel combustion) of Jamaica in 2007 to that in 2011?
Provide a short and direct response. 0.87. What is the ratio of the CO2 emissions (% of total fuel combustion) of Lower middle income in 2008 to that in 2009?
Your response must be concise. 1.08. What is the ratio of the CO2 emissions (% of total fuel combustion) in Austria in 2008 to that in 2009?
Give a very brief answer. 0.97. What is the ratio of the CO2 emissions (% of total fuel combustion) in Congo (Republic) in 2008 to that in 2009?
Keep it short and to the point. 0.91. What is the ratio of the CO2 emissions (% of total fuel combustion) of Jamaica in 2008 to that in 2009?
Offer a very short reply. 0.97. What is the ratio of the CO2 emissions (% of total fuel combustion) in Lower middle income in 2008 to that in 2010?
Give a very brief answer. 1.1. What is the ratio of the CO2 emissions (% of total fuel combustion) of Austria in 2008 to that in 2010?
Give a very brief answer. 1.02. What is the ratio of the CO2 emissions (% of total fuel combustion) of Congo (Republic) in 2008 to that in 2010?
Your answer should be very brief. 0.98. What is the ratio of the CO2 emissions (% of total fuel combustion) of Jamaica in 2008 to that in 2010?
Offer a terse response. 1.19. What is the ratio of the CO2 emissions (% of total fuel combustion) of Lower middle income in 2008 to that in 2011?
Ensure brevity in your answer.  1.1. What is the ratio of the CO2 emissions (% of total fuel combustion) of Austria in 2008 to that in 2011?
Offer a terse response. 1.13. What is the ratio of the CO2 emissions (% of total fuel combustion) of Congo (Republic) in 2008 to that in 2011?
Your response must be concise. 1.23. What is the ratio of the CO2 emissions (% of total fuel combustion) of Jamaica in 2008 to that in 2011?
Your answer should be compact. 1.21. What is the ratio of the CO2 emissions (% of total fuel combustion) of Lower middle income in 2009 to that in 2010?
Your response must be concise. 1.02. What is the ratio of the CO2 emissions (% of total fuel combustion) of Austria in 2009 to that in 2010?
Offer a very short reply. 1.05. What is the ratio of the CO2 emissions (% of total fuel combustion) of Congo (Republic) in 2009 to that in 2010?
Provide a short and direct response. 1.08. What is the ratio of the CO2 emissions (% of total fuel combustion) in Jamaica in 2009 to that in 2010?
Your response must be concise. 1.23. What is the ratio of the CO2 emissions (% of total fuel combustion) in Lower middle income in 2009 to that in 2011?
Your answer should be very brief. 1.02. What is the ratio of the CO2 emissions (% of total fuel combustion) in Austria in 2009 to that in 2011?
Make the answer very short. 1.17. What is the ratio of the CO2 emissions (% of total fuel combustion) in Congo (Republic) in 2009 to that in 2011?
Offer a terse response. 1.35. What is the ratio of the CO2 emissions (% of total fuel combustion) of Jamaica in 2009 to that in 2011?
Make the answer very short. 1.25. What is the ratio of the CO2 emissions (% of total fuel combustion) in Lower middle income in 2010 to that in 2011?
Your answer should be very brief. 1. What is the ratio of the CO2 emissions (% of total fuel combustion) in Austria in 2010 to that in 2011?
Ensure brevity in your answer.  1.11. What is the ratio of the CO2 emissions (% of total fuel combustion) in Congo (Republic) in 2010 to that in 2011?
Make the answer very short. 1.25. What is the ratio of the CO2 emissions (% of total fuel combustion) in Jamaica in 2010 to that in 2011?
Offer a terse response. 1.02. What is the difference between the highest and the second highest CO2 emissions (% of total fuel combustion) of Lower middle income?
Give a very brief answer. 0.29. What is the difference between the highest and the second highest CO2 emissions (% of total fuel combustion) in Austria?
Offer a very short reply. 0.18. What is the difference between the highest and the second highest CO2 emissions (% of total fuel combustion) of Congo (Republic)?
Your answer should be very brief. 0.63. What is the difference between the highest and the second highest CO2 emissions (% of total fuel combustion) in Jamaica?
Your answer should be compact. 0.16. What is the difference between the highest and the lowest CO2 emissions (% of total fuel combustion) in Lower middle income?
Make the answer very short. 1.95. What is the difference between the highest and the lowest CO2 emissions (% of total fuel combustion) in Austria?
Your answer should be compact. 3.08. What is the difference between the highest and the lowest CO2 emissions (% of total fuel combustion) in Congo (Republic)?
Your response must be concise. 2.37. What is the difference between the highest and the lowest CO2 emissions (% of total fuel combustion) of Jamaica?
Ensure brevity in your answer.  1.48. 